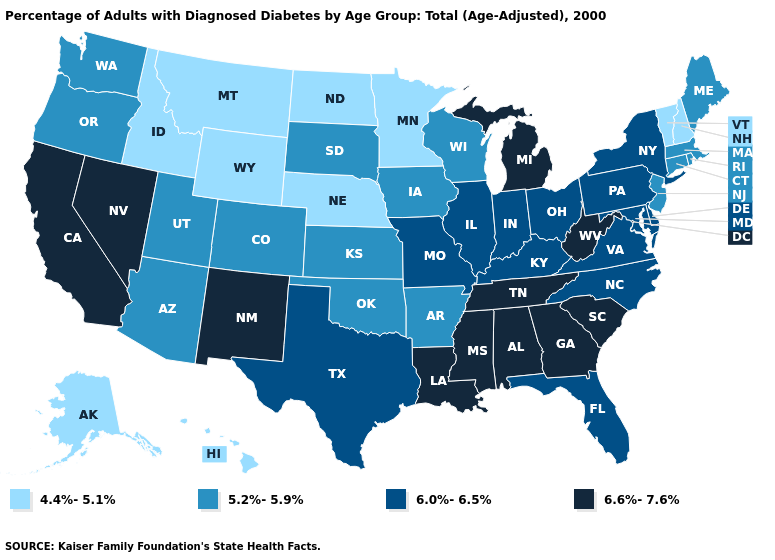Name the states that have a value in the range 6.0%-6.5%?
Answer briefly. Delaware, Florida, Illinois, Indiana, Kentucky, Maryland, Missouri, New York, North Carolina, Ohio, Pennsylvania, Texas, Virginia. Does Montana have the same value as Minnesota?
Write a very short answer. Yes. What is the value of Pennsylvania?
Write a very short answer. 6.0%-6.5%. What is the value of North Dakota?
Be succinct. 4.4%-5.1%. Among the states that border Arizona , does New Mexico have the highest value?
Short answer required. Yes. Does Ohio have a lower value than Delaware?
Answer briefly. No. How many symbols are there in the legend?
Keep it brief. 4. What is the value of Missouri?
Concise answer only. 6.0%-6.5%. Does Idaho have the lowest value in the West?
Quick response, please. Yes. Does Idaho have the lowest value in the USA?
Quick response, please. Yes. Which states have the highest value in the USA?
Quick response, please. Alabama, California, Georgia, Louisiana, Michigan, Mississippi, Nevada, New Mexico, South Carolina, Tennessee, West Virginia. What is the value of Connecticut?
Write a very short answer. 5.2%-5.9%. What is the value of Pennsylvania?
Give a very brief answer. 6.0%-6.5%. Which states hav the highest value in the South?
Quick response, please. Alabama, Georgia, Louisiana, Mississippi, South Carolina, Tennessee, West Virginia. 